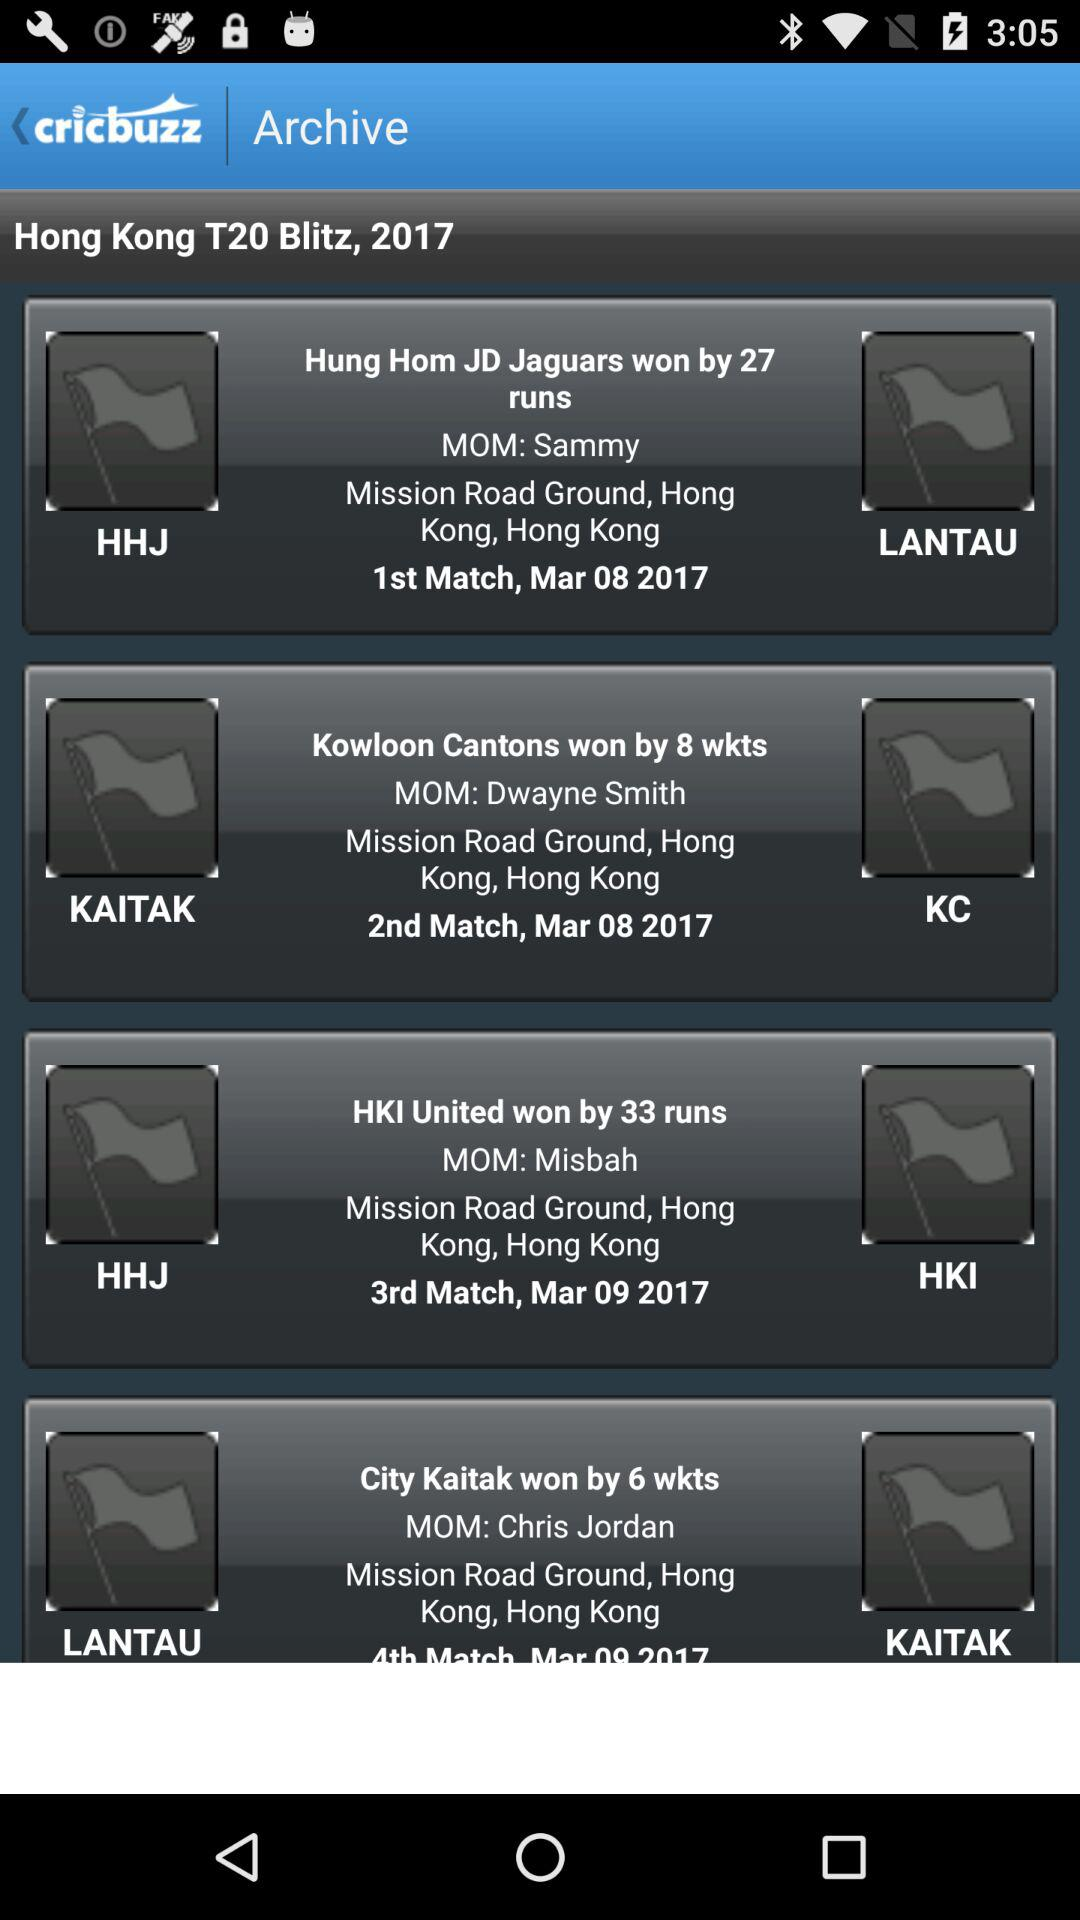What is the location of the 1st match? The location of the 1st match is Mission Road Ground, Hong Kong. 